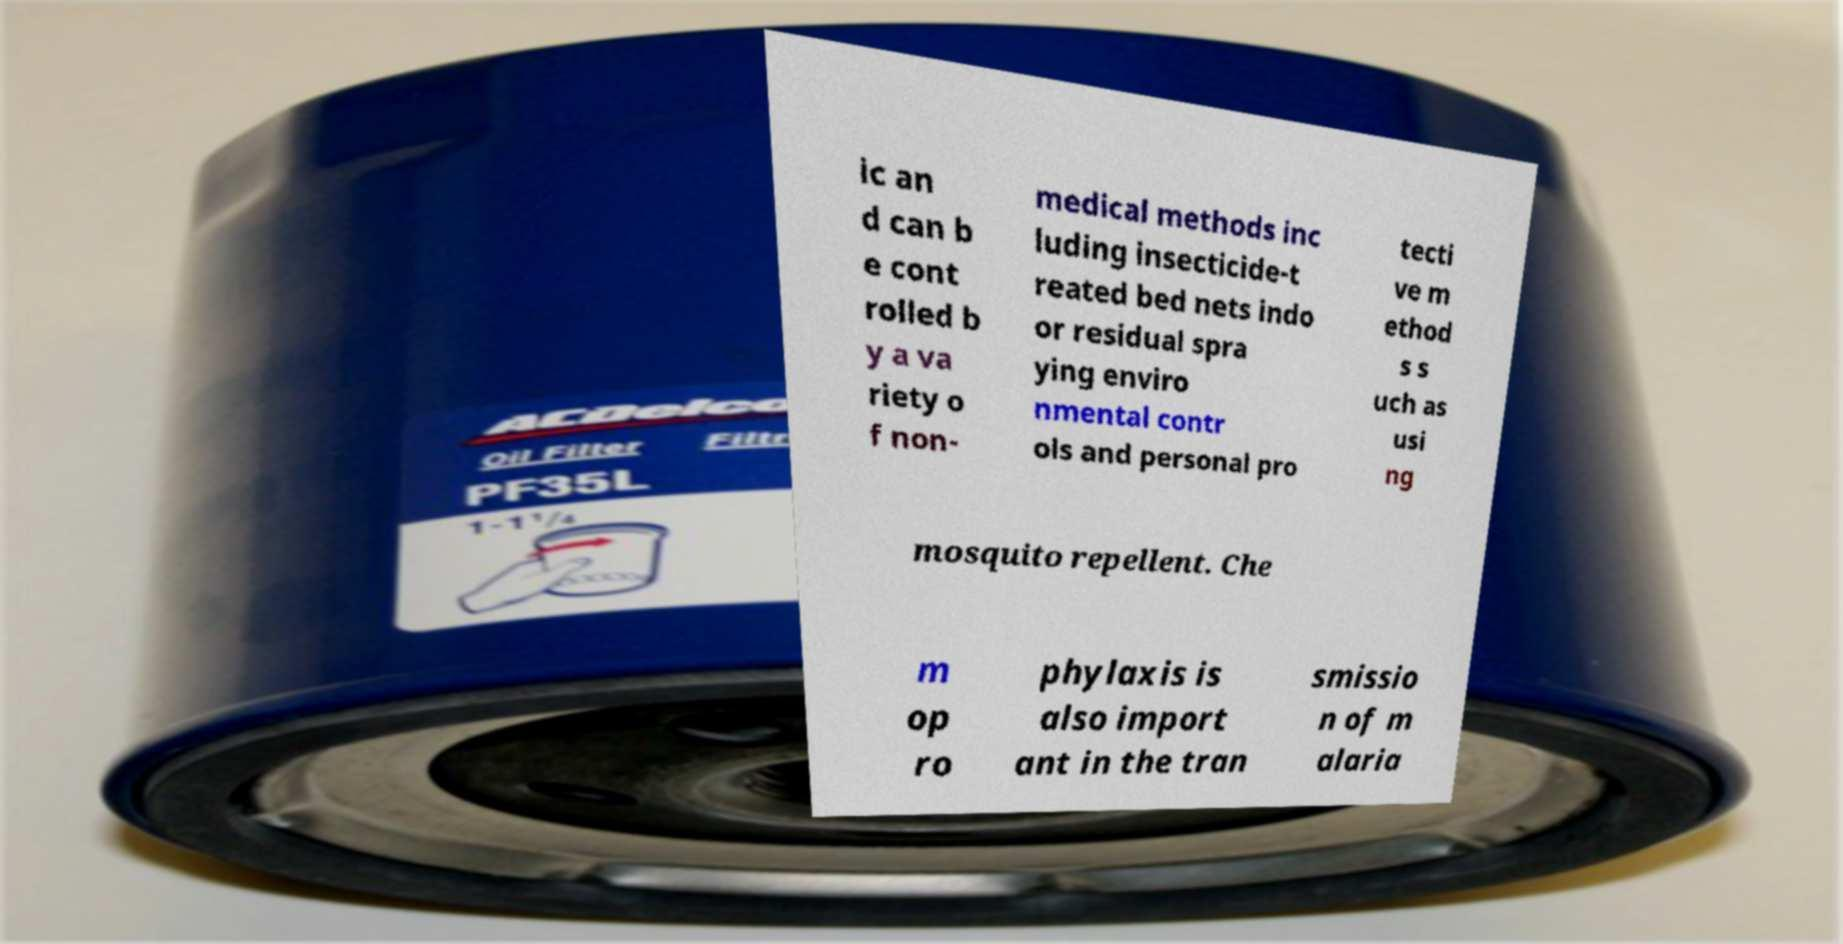Can you accurately transcribe the text from the provided image for me? ic an d can b e cont rolled b y a va riety o f non- medical methods inc luding insecticide-t reated bed nets indo or residual spra ying enviro nmental contr ols and personal pro tecti ve m ethod s s uch as usi ng mosquito repellent. Che m op ro phylaxis is also import ant in the tran smissio n of m alaria 